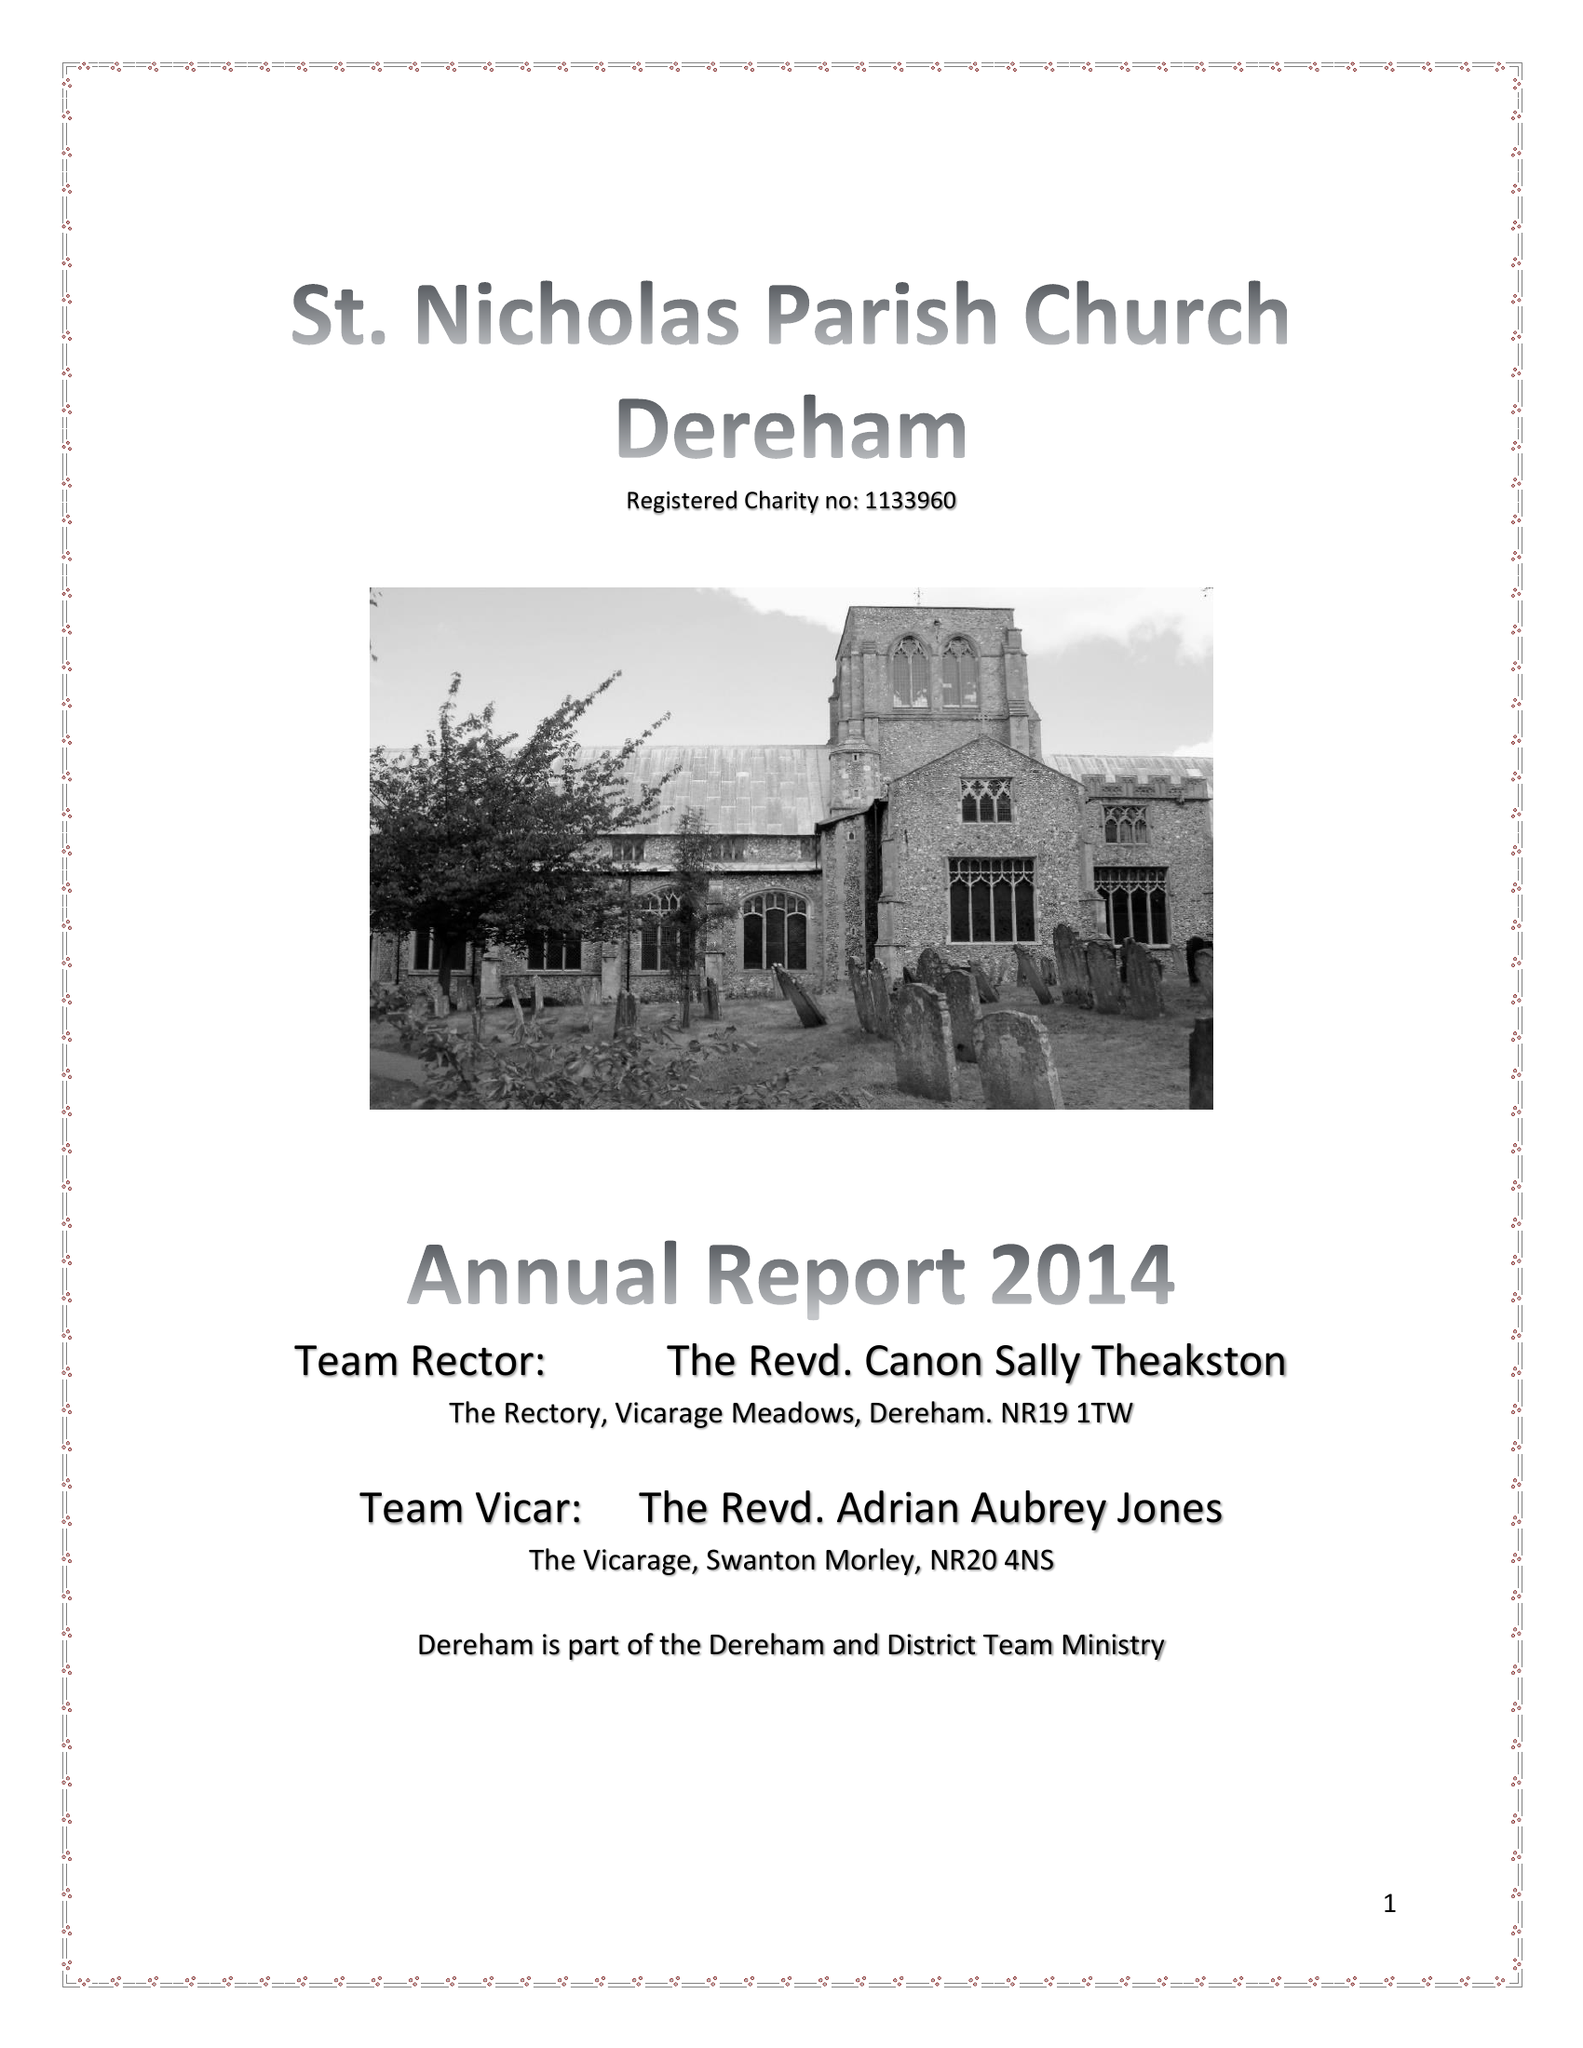What is the value for the address__post_town?
Answer the question using a single word or phrase. DEREHAM 